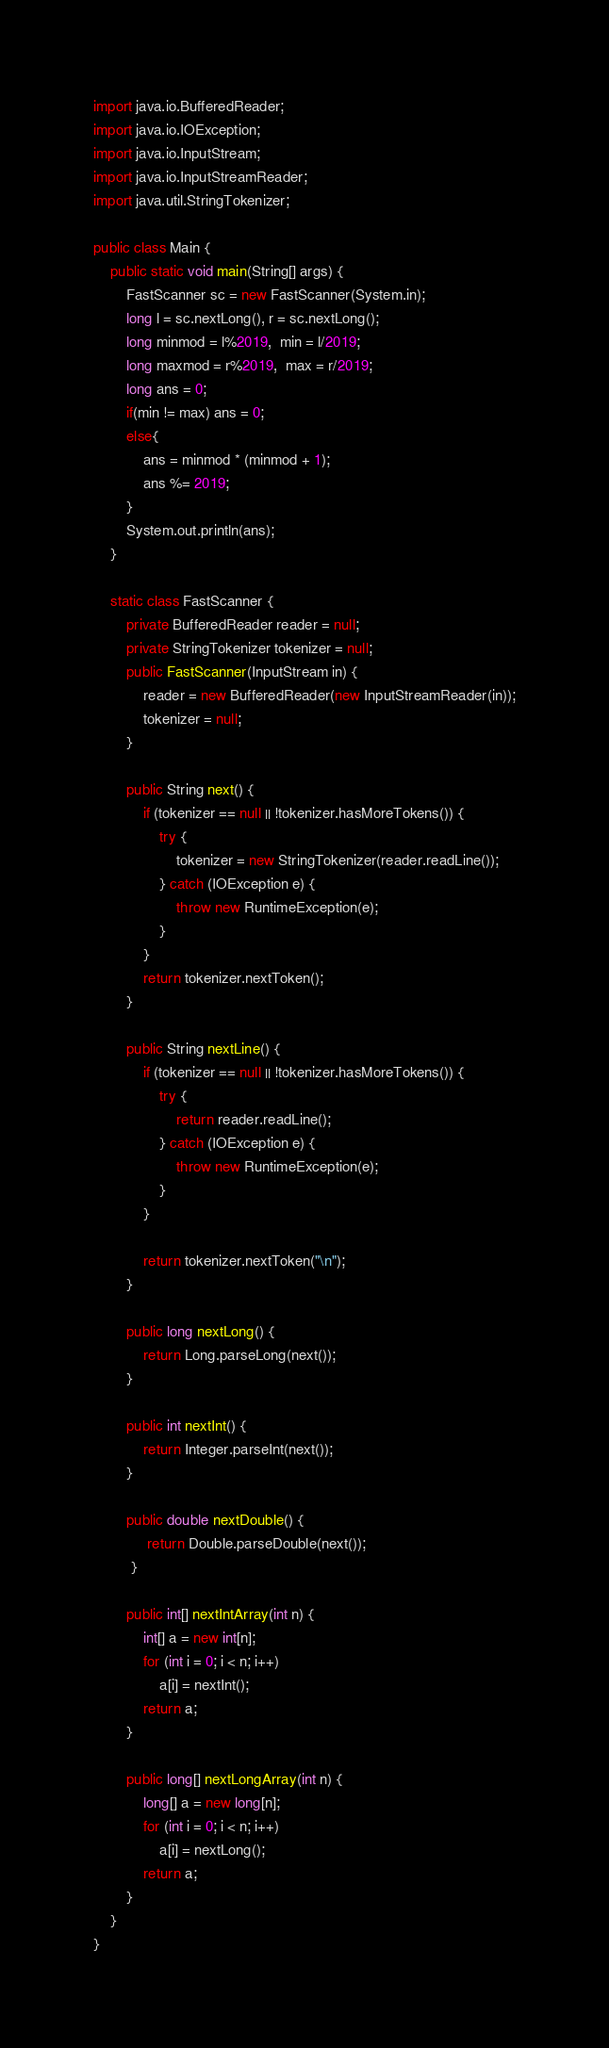Convert code to text. <code><loc_0><loc_0><loc_500><loc_500><_Java_>import java.io.BufferedReader;
import java.io.IOException;
import java.io.InputStream;
import java.io.InputStreamReader;
import java.util.StringTokenizer;

public class Main {
	public static void main(String[] args) {
		FastScanner sc = new FastScanner(System.in);
		long l = sc.nextLong(), r = sc.nextLong();
		long minmod = l%2019,  min = l/2019;
		long maxmod = r%2019,  max = r/2019;
		long ans = 0;
		if(min != max) ans = 0;
		else{
			ans = minmod * (minmod + 1);
			ans %= 2019;
		}
		System.out.println(ans);
	}
	
	static class FastScanner {
		private BufferedReader reader = null;
	    private StringTokenizer tokenizer = null;
	    public FastScanner(InputStream in) {
	        reader = new BufferedReader(new InputStreamReader(in));
	        tokenizer = null;
	    }

	    public String next() {
	        if (tokenizer == null || !tokenizer.hasMoreTokens()) {
	            try {
	                tokenizer = new StringTokenizer(reader.readLine());
	            } catch (IOException e) {
	                throw new RuntimeException(e);
	            }
	        }
	        return tokenizer.nextToken();
	    }

	    public String nextLine() {
	        if (tokenizer == null || !tokenizer.hasMoreTokens()) {
	            try {
	                return reader.readLine();
	            } catch (IOException e) {
	                throw new RuntimeException(e);
	            }
	        }

	        return tokenizer.nextToken("\n");
	    }

	    public long nextLong() {
	        return Long.parseLong(next());
	    }

	    public int nextInt() {
	        return Integer.parseInt(next());
	    }

	    public double nextDouble() {
	         return Double.parseDouble(next());
	     }

	    public int[] nextIntArray(int n) {
	        int[] a = new int[n];
	        for (int i = 0; i < n; i++)
	            a[i] = nextInt();
	        return a;
	    }

	    public long[] nextLongArray(int n) {
	        long[] a = new long[n];
	        for (int i = 0; i < n; i++)
	            a[i] = nextLong();
	        return a;
	    }
	}
}
</code> 